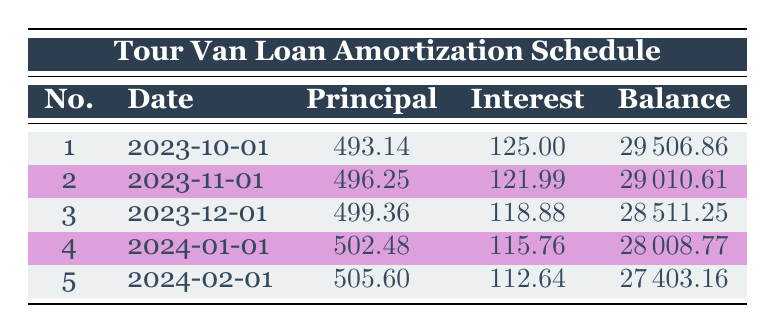What is the interest payment for the first month? The first month shows an interest payment of 125.00 in the table.
Answer: 125.00 How much was the principal payment in the second month? The second month lists a principal payment of 496.25 in the table.
Answer: 496.25 What is the remaining balance after the fourth payment? After the fourth payment, the table indicates a remaining balance of 28008.77.
Answer: 28008.77 How much total principal payment is made in the first three payments? The principal payments for the first three months are 493.14, 496.25, and 499.36. Adding these gives (493.14 + 496.25 + 499.36) = 1488.75.
Answer: 1488.75 Is the interest payment for the third month higher than that of the second month? The table shows that the interest payment for the third month is 118.88, while for the second month it is 121.99. Since 118.88 is less than 121.99, the answer is no.
Answer: No What will be the total interest paid by the end of the fifth month? The interest payments for the first five months are 125.00, 121.99, 118.88, 115.76, and 112.64. Adding these gives a total of (125.00 + 121.99 + 118.88 + 115.76 + 112.64) = 594.27.
Answer: 594.27 What is the average principal payment made over the first five payments? The principal payments are 493.14, 496.25, 499.36, 502.48, and 505.60. To find the average, we sum these payments (493.14 + 496.25 + 499.36 + 502.48 + 505.60) = 2496.83 and divide by 5, resulting in 2496.83 / 5 = 499.37.
Answer: 499.37 Is the remaining balance after the third payment less than 28500? The remaining balance after the third payment in the table is 28511.25, which is not less than 28500. Hence, the answer is no.
Answer: No How much did the remaining balance decrease from the first payment to the fifth payment? The remaining balance after the first payment is 29506.86, and after the fifth payment, it is 27403.16. The decrease is (29506.86 - 27403.16) = 1103.70.
Answer: 1103.70 